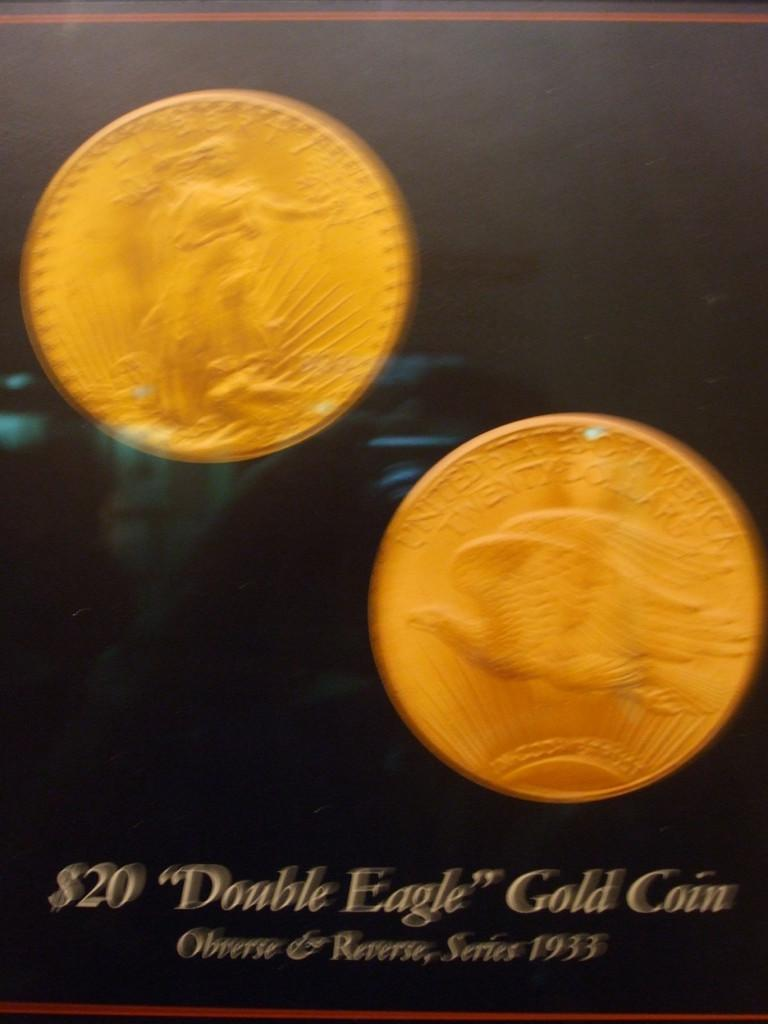<image>
Present a compact description of the photo's key features. An ad for the Double Eagle gold coin has the date 1933 on it. 